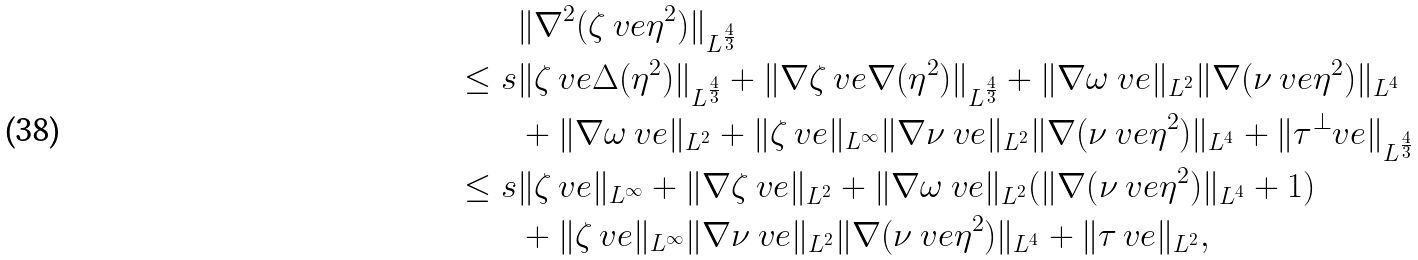<formula> <loc_0><loc_0><loc_500><loc_500>& \| \nabla ^ { 2 } ( \zeta _ { \ } v e \eta ^ { 2 } ) \| _ { L ^ { \frac { 4 } { 3 } } } \\ \leq s & \| \zeta _ { \ } v e \Delta ( \eta ^ { 2 } ) \| _ { L ^ { \frac { 4 } { 3 } } } + \| \nabla \zeta _ { \ } v e \nabla ( \eta ^ { 2 } ) \| _ { L ^ { \frac { 4 } { 3 } } } + \| \nabla \omega _ { \ } v e \| _ { L ^ { 2 } } \| \nabla ( \nu _ { \ } v e \eta ^ { 2 } ) \| _ { L ^ { 4 } } \\ & + \| \nabla \omega _ { \ } v e \| _ { L ^ { 2 } } + \| \zeta _ { \ } v e \| _ { L ^ { \infty } } \| \nabla \nu _ { \ } v e \| _ { L ^ { 2 } } \| \nabla ( \nu _ { \ } v e \eta ^ { 2 } ) \| _ { L ^ { 4 } } + \| \tau ^ { \perp } _ { \ } v e \| _ { L ^ { \frac { 4 } { 3 } } } \\ \leq s & \| \zeta _ { \ } v e \| _ { L ^ { \infty } } + \| \nabla \zeta _ { \ } v e \| _ { L ^ { 2 } } + \| \nabla \omega _ { \ } v e \| _ { L ^ { 2 } } ( \| \nabla ( \nu _ { \ } v e \eta ^ { 2 } ) \| _ { L ^ { 4 } } + 1 ) \\ & + \| \zeta _ { \ } v e \| _ { L ^ { \infty } } \| \nabla \nu _ { \ } v e \| _ { L ^ { 2 } } \| \nabla ( \nu _ { \ } v e \eta ^ { 2 } ) \| _ { L ^ { 4 } } + \| \tau _ { \ } v e \| _ { L ^ { 2 } } ,</formula> 